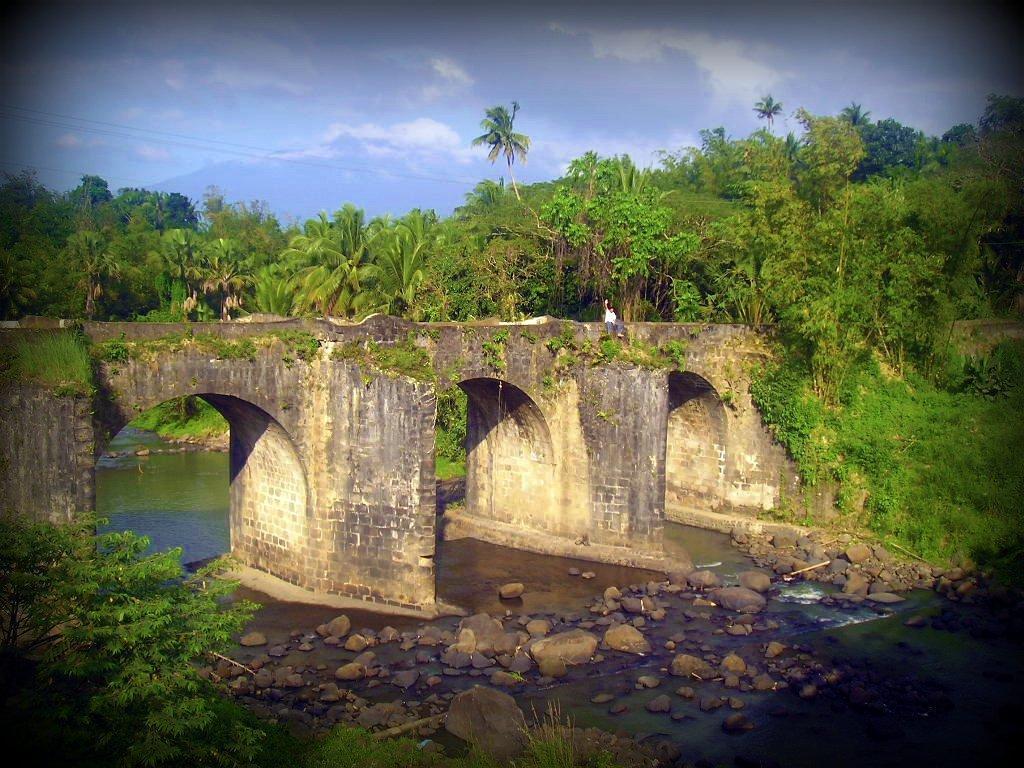In one or two sentences, can you explain what this image depicts? In this image I can see few trees, stones and the water. I can see the bridge and the person. The sky is in white and blue color. 